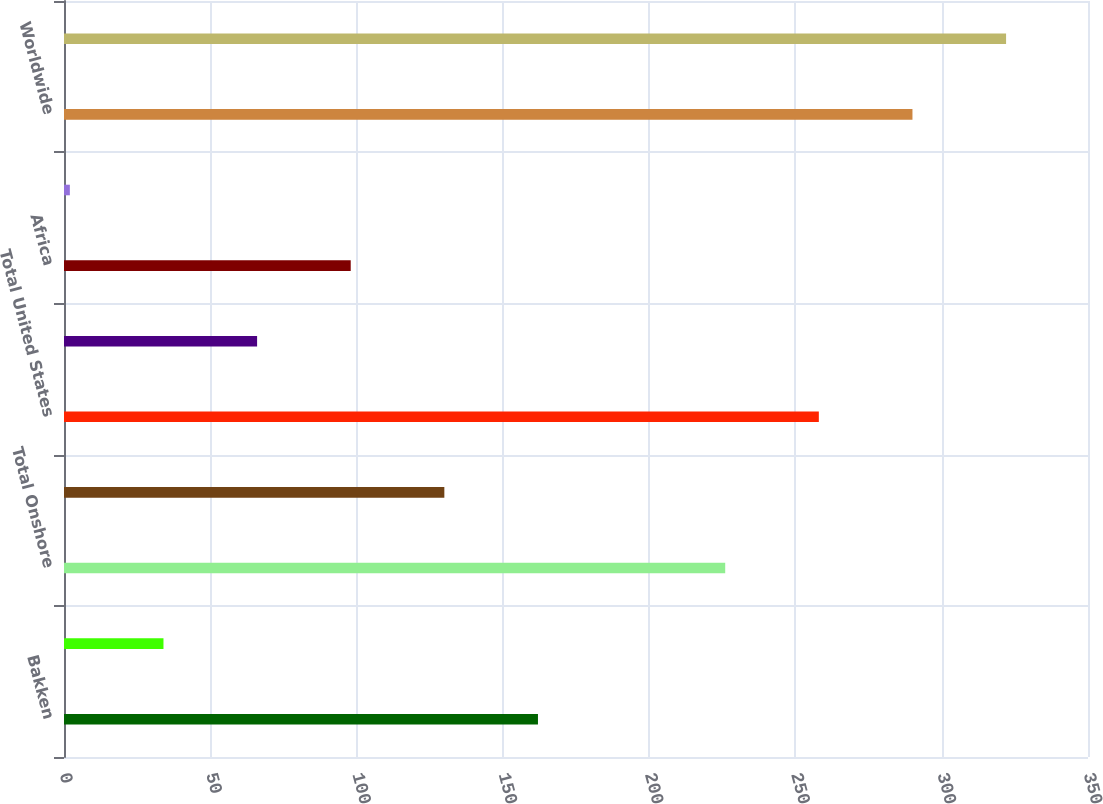<chart> <loc_0><loc_0><loc_500><loc_500><bar_chart><fcel>Bakken<fcel>Other Onshore<fcel>Total Onshore<fcel>Offshore<fcel>Total United States<fcel>Europe<fcel>Africa<fcel>Asia<fcel>Worldwide<fcel>Asia and other<nl><fcel>162<fcel>34<fcel>226<fcel>130<fcel>258<fcel>66<fcel>98<fcel>2<fcel>290<fcel>322<nl></chart> 